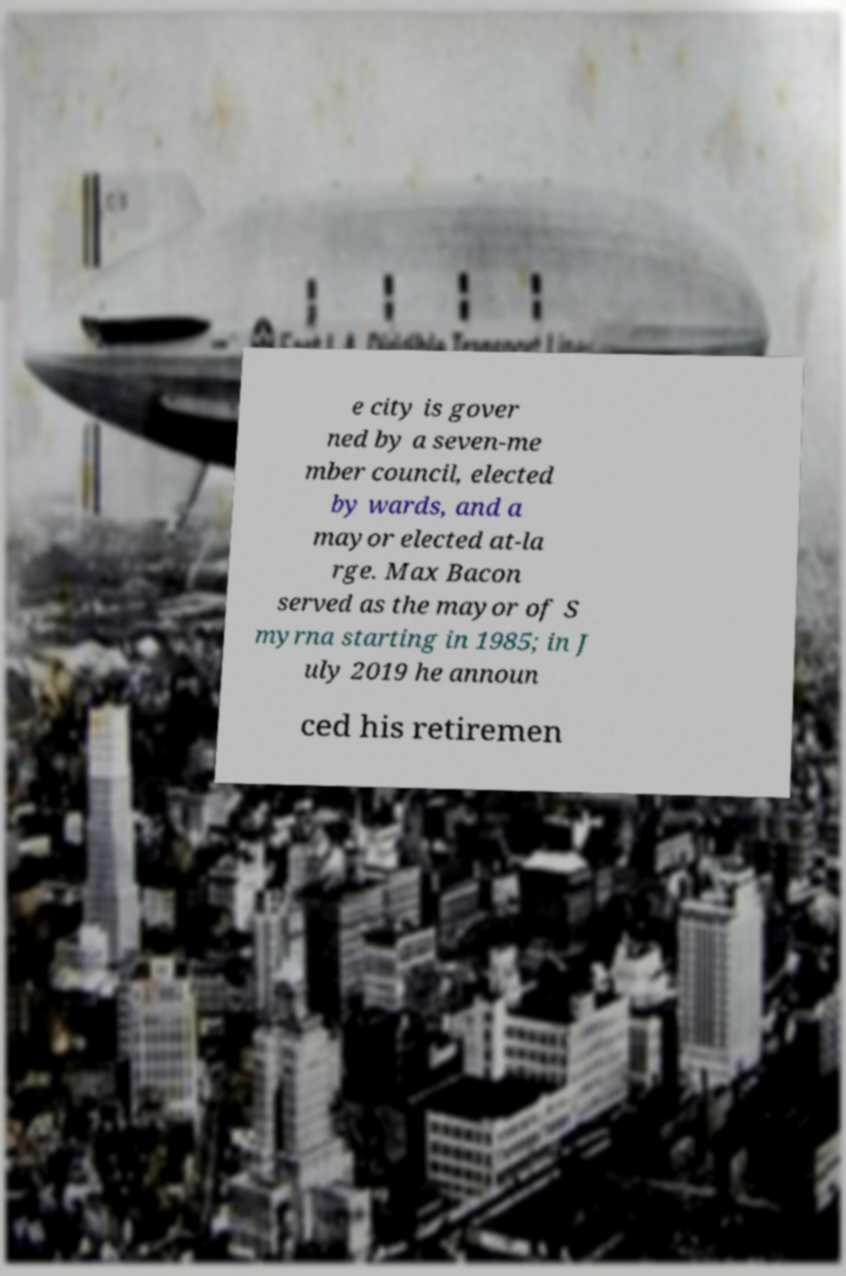Please read and relay the text visible in this image. What does it say? e city is gover ned by a seven-me mber council, elected by wards, and a mayor elected at-la rge. Max Bacon served as the mayor of S myrna starting in 1985; in J uly 2019 he announ ced his retiremen 